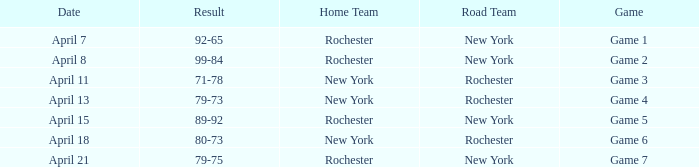Which Result has a Home Team of rochester, and a Game of game 5? 89-92. Parse the full table. {'header': ['Date', 'Result', 'Home Team', 'Road Team', 'Game'], 'rows': [['April 7', '92-65', 'Rochester', 'New York', 'Game 1'], ['April 8', '99-84', 'Rochester', 'New York', 'Game 2'], ['April 11', '71-78', 'New York', 'Rochester', 'Game 3'], ['April 13', '79-73', 'New York', 'Rochester', 'Game 4'], ['April 15', '89-92', 'Rochester', 'New York', 'Game 5'], ['April 18', '80-73', 'New York', 'Rochester', 'Game 6'], ['April 21', '79-75', 'Rochester', 'New York', 'Game 7']]} 